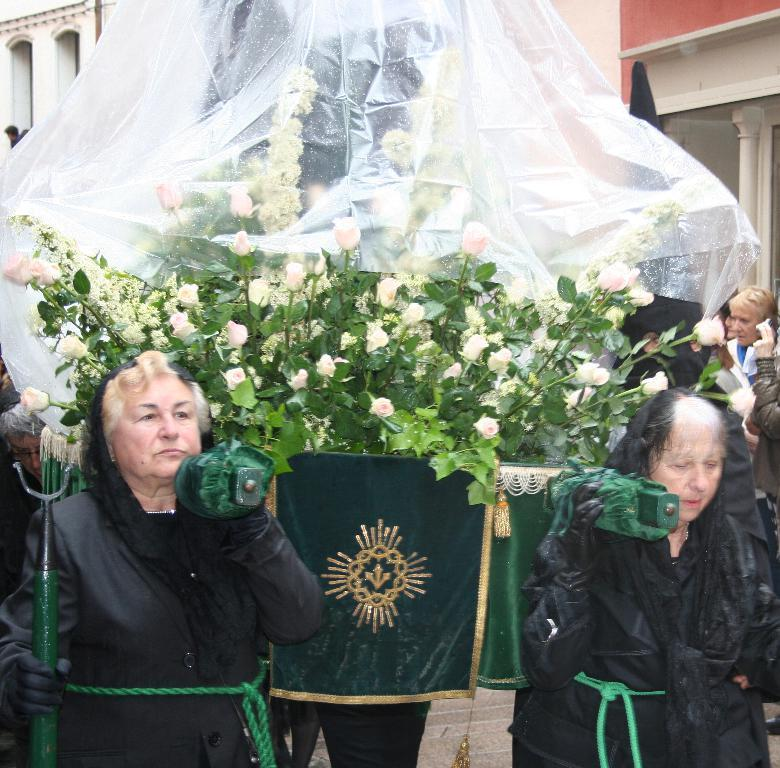How many people are present in the image? There is a group of people in the image, but the exact number cannot be determined from the provided facts. What type of vegetation can be seen in the image? There are plants and flowers in the image. What other items can be seen in the image besides the people and vegetation? There are objects in the image. What can be seen in the background of the image? There is a wall, pillars, and additional objects in the background of the image. What type of feast is being prepared in the image? There is no indication of a feast or any food preparation in the image. What system is being used to organize the objects in the image? There is no mention of a system for organizing the objects in the image. What journey are the people in the image embarking on? There is no indication of a journey or any travel-related activity in the image. 